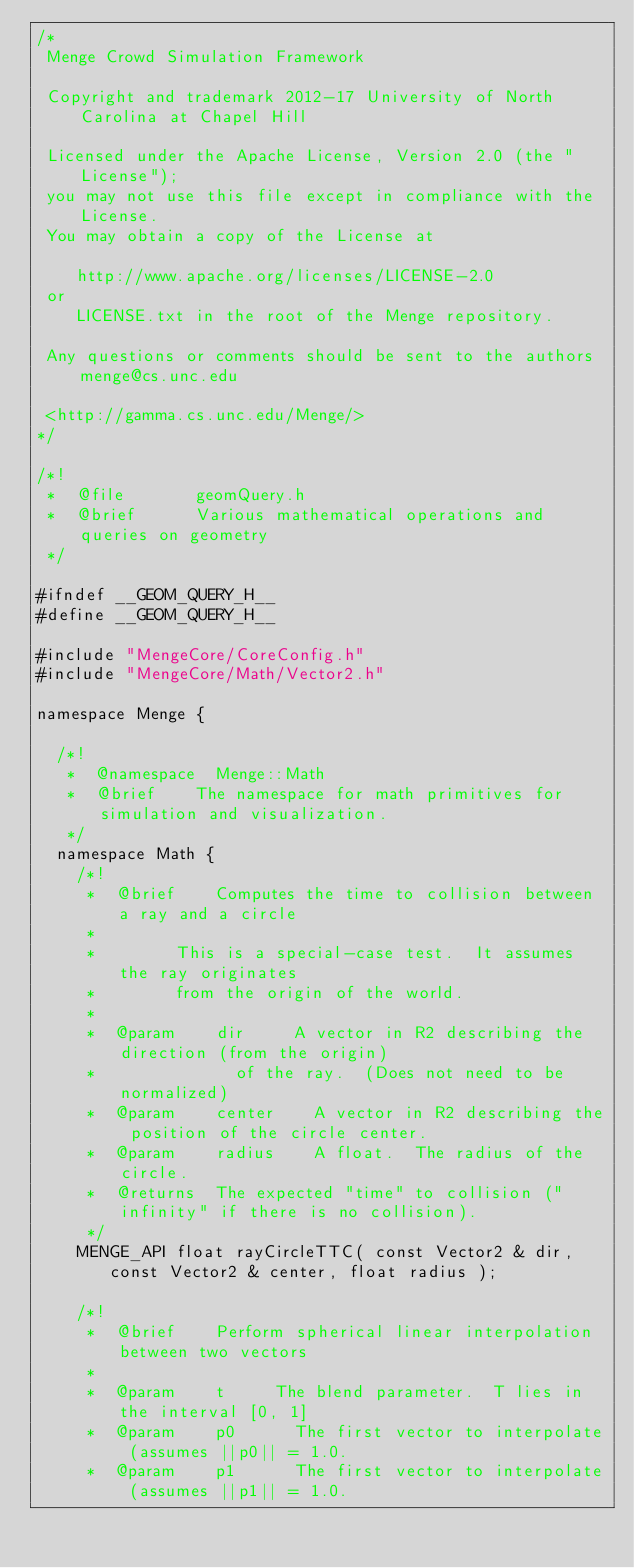<code> <loc_0><loc_0><loc_500><loc_500><_C_>/*
 Menge Crowd Simulation Framework

 Copyright and trademark 2012-17 University of North Carolina at Chapel Hill

 Licensed under the Apache License, Version 2.0 (the "License");
 you may not use this file except in compliance with the License.
 You may obtain a copy of the License at

    http://www.apache.org/licenses/LICENSE-2.0
 or
    LICENSE.txt in the root of the Menge repository.

 Any questions or comments should be sent to the authors menge@cs.unc.edu

 <http://gamma.cs.unc.edu/Menge/>
*/

/*!
 *  @file       geomQuery.h
 *  @brief      Various mathematical operations and queries on geometry
 */

#ifndef __GEOM_QUERY_H__
#define	__GEOM_QUERY_H__

#include "MengeCore/CoreConfig.h"
#include "MengeCore/Math/Vector2.h"

namespace Menge {

	/*!
	 *	@namespace	Menge::Math
	 *	@brief		The namespace for math primitives for simulation and visualization.
	 */
	namespace Math {
		/*!
		 *	@brief		Computes the time to collision between a ray and a circle
		 *
		 *				This is a special-case test.  It assumes the ray originates
		 *				from the origin of the world.
		 *
		 *	@param		dir			A vector in R2 describing the direction (from the origin)
		 *							of the ray.  (Does not need to be normalized)
		 *	@param		center		A vector in R2 describing the position of the circle center.
		 *	@param		radius		A float.  The radius of the circle.
		 *	@returns	The expected "time" to collision ("infinity" if there is no collision).
		 */
		MENGE_API float rayCircleTTC( const Vector2 & dir, const Vector2 & center, float radius );

		/*!
		 *	@brief		Perform spherical linear interpolation between two vectors
		 *
		 *	@param		t			The blend parameter.  T lies in the interval [0, 1]
		 *	@param		p0			The first vector to interpolate (assumes ||p0|| = 1.0.
		 *	@param		p1			The first vector to interpolate (assumes ||p1|| = 1.0.</code> 